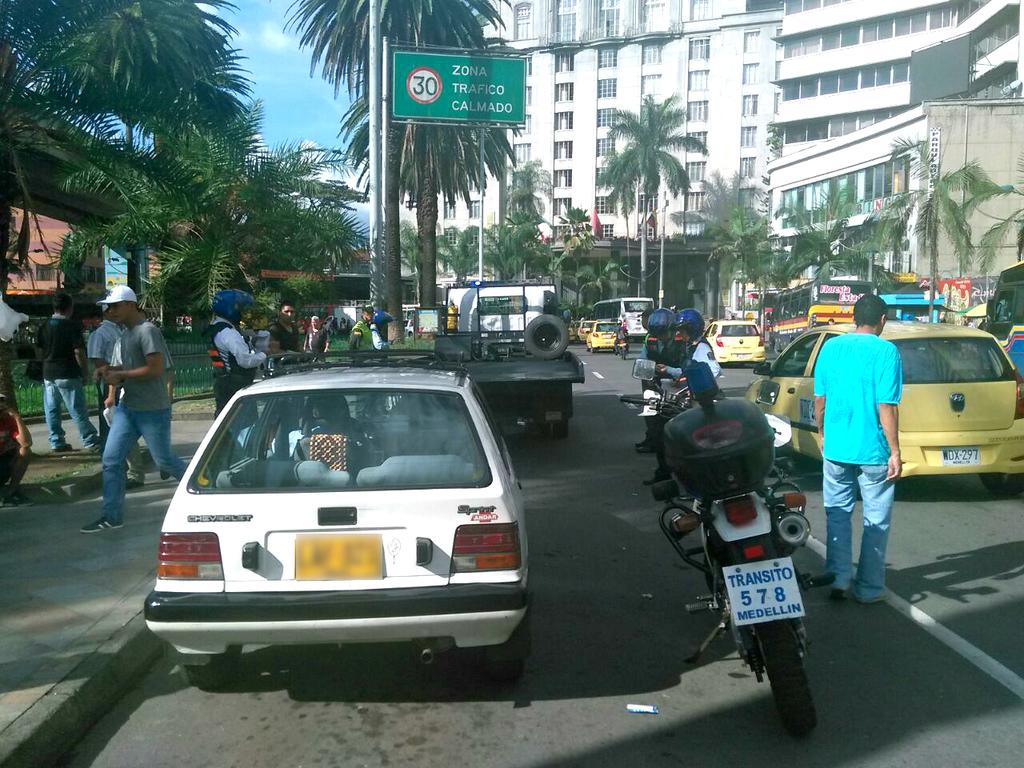<image>
Summarize the visual content of the image. the number 578 is on the plate of a motorcycle 